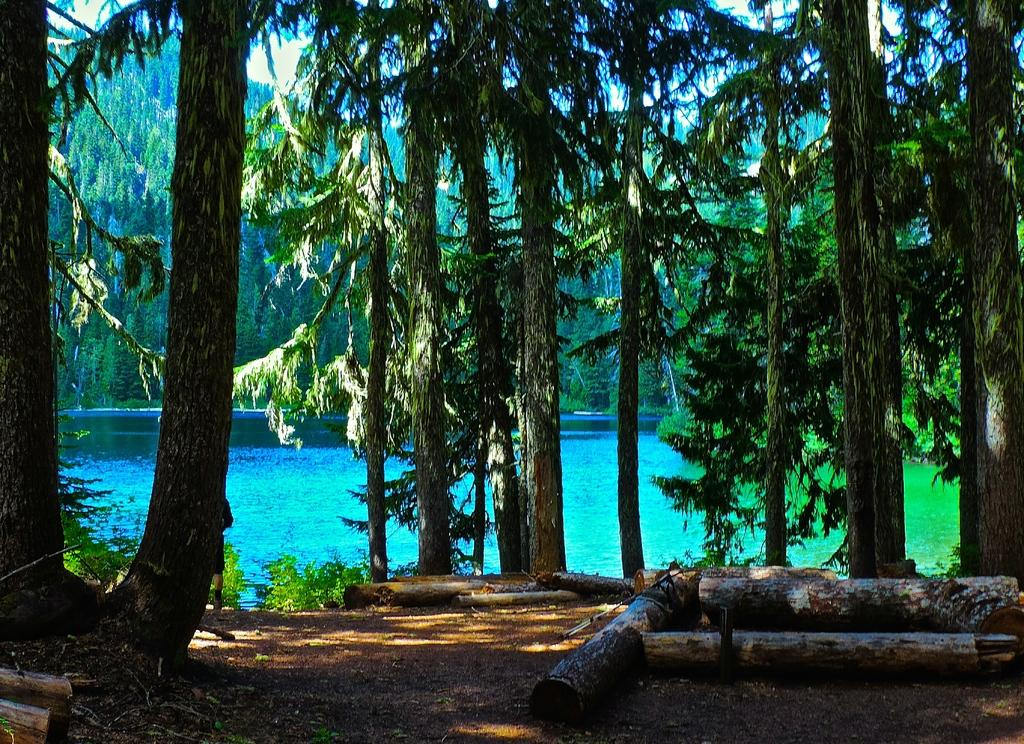What type of vegetation can be seen in the image? There are trees in the image. What part of the trees is visible in the image? Tree trunks are visible in the image. What natural feature is present in the image besides trees? There is a body of water in the image. How is the water in the image behaving? The water appears to be flowing. Can you see an owl perched on one of the tree branches in the image? There is no owl present in the image. What type of reward is being offered for finding a sponge in the image? There is no mention of a reward or a sponge in the image. 